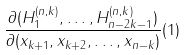Convert formula to latex. <formula><loc_0><loc_0><loc_500><loc_500>\frac { \partial ( H _ { 1 } ^ { ( n , k ) } , \dots , H _ { n - 2 k - 1 } ^ { ( n , k ) } ) } { \partial ( x _ { k + 1 } , x _ { k + 2 } , \dots , x _ { n - k } ) } ( { 1 } )</formula> 